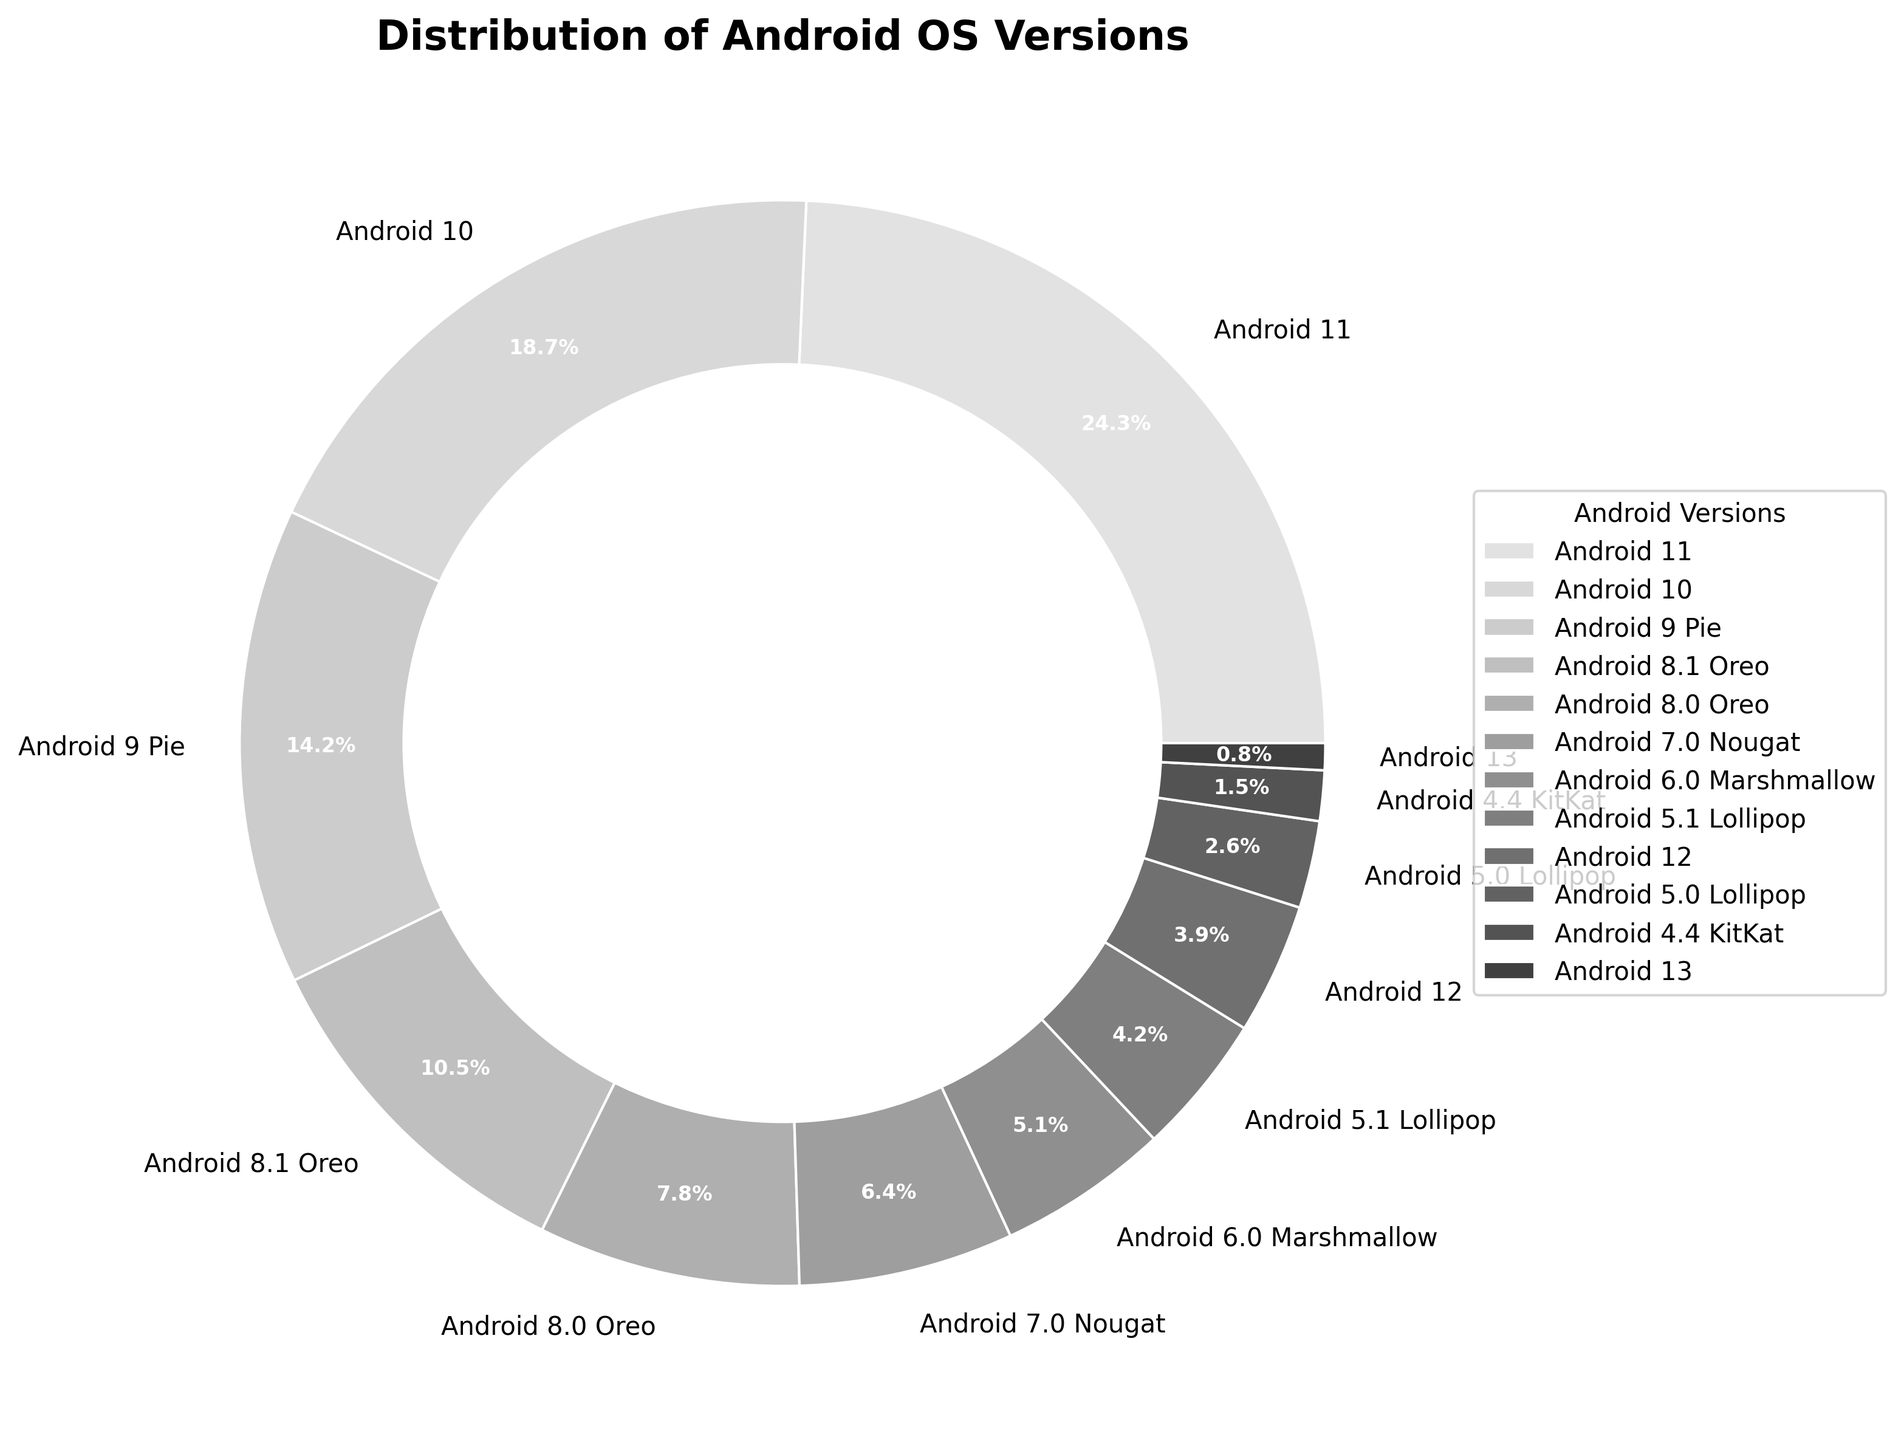What is the most common Android OS version among active devices? The pie chart shows percentages of each Android version being used. The largest segment is labeled "Android 11" with a percentage of 24.3%, indicating it is the most common version.
Answer: Android 11 Which Android OS versions together make up more than 50% of the market share? By adding percentages from the largest segments: Android 11 (24.3%) + Android 10 (18.7%) + Android 9 Pie (14.2%), we get 57.2%, which is more than 50%.
Answer: Android 11, Android 10, Android 9 Pie What percentage of devices run on Android versions older than Nougat (7.0)? Summing the percentages for Android 6.0 Marshmallow (5.1%) + Android 5.1 Lollipop (4.2%) + Android 5.0 Lollipop (2.6%) + Android 4.4 KitKat (1.5%) gives 13.4%.
Answer: 13.4% Which OS versions make up at least one-tenth of the market share each? One-tenth of 100% is 10%. The chart shows Android 11 (24.3%), Android 10 (18.7%), and Android 9 Pie (14.2%) exceeding this value.
Answer: Android 11, Android 10, Android 9 Pie What is the difference in market share between Android 8.1 Oreo and Android 8.0 Oreo? The percentage for Android 8.1 Oreo is 10.5% and for Android 8.0 Oreo is 7.8%. Subtracting these gives 10.5% - 7.8% = 2.7%.
Answer: 2.7% Which has a larger share, Android 12 or Android 5.1 Lollipop, and by how much? Android 12 has 3.9% and Android 5.1 Lollipop has 4.2%. The difference is 4.2% - 3.9% = 0.3%, and Android 5.1 Lollipop has the larger share.
Answer: Android 5.1 Lollipop by 0.3% What is the combined market share of all 'Lollipop' versions (5.0 and 5.1)? Summing the percentages for Android 5.1 Lollipop (4.2%) and Android 5.0 Lollipop (2.6%) gives 4.2% + 2.6% = 6.8%.
Answer: 6.8% What fraction of the market does Android 13 occupy compared to Android 12? Android 13 has 0.8% and Android 12 has 3.9%. The fraction is 0.8 / 3.9, which approximately equals 0.205 or roughly 1/5.
Answer: 1/5 Is the percentage of devices running Android 6.0 Marshmallow closer to that of Android 7.0 Nougat or Android 5.1 Lollipop? Android 6.0 Marshmallow has 5.1%. Comparing with Android 7.0 Nougat (6.4%) and Android 5.1 Lollipop (4.2%): 6.4% - 5.1% = 1.3% while 5.1% - 4.2% = 0.9%, thus closer to Android 5.1 Lollipop.
Answer: Android 5.1 Lollipop Which three consecutive Android versions have the smallest combined market share? Observing the figure, Android 13 (0.8%), Android 4.4 KitKat (1.5%), and Android 5.0 Lollipop (2.6%) are consecutive with the smallest combined share: 0.8% + 1.5% + 2.6% = 4.9%.
Answer: Android 13, Android 4.4 KitKat, Android 5.0 Lollipop 